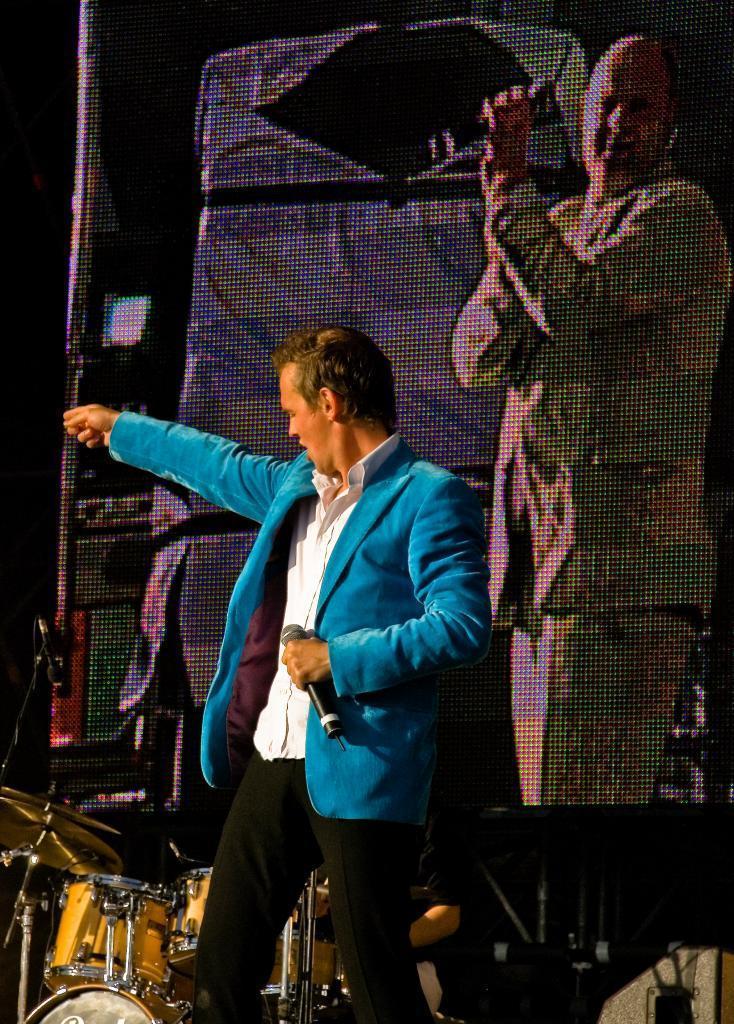How would you summarize this image in a sentence or two? In this image I can see a person holding a mike and wearing a blue color jacket ,in front of him I can see musical instruments,at the top I can see person image. 